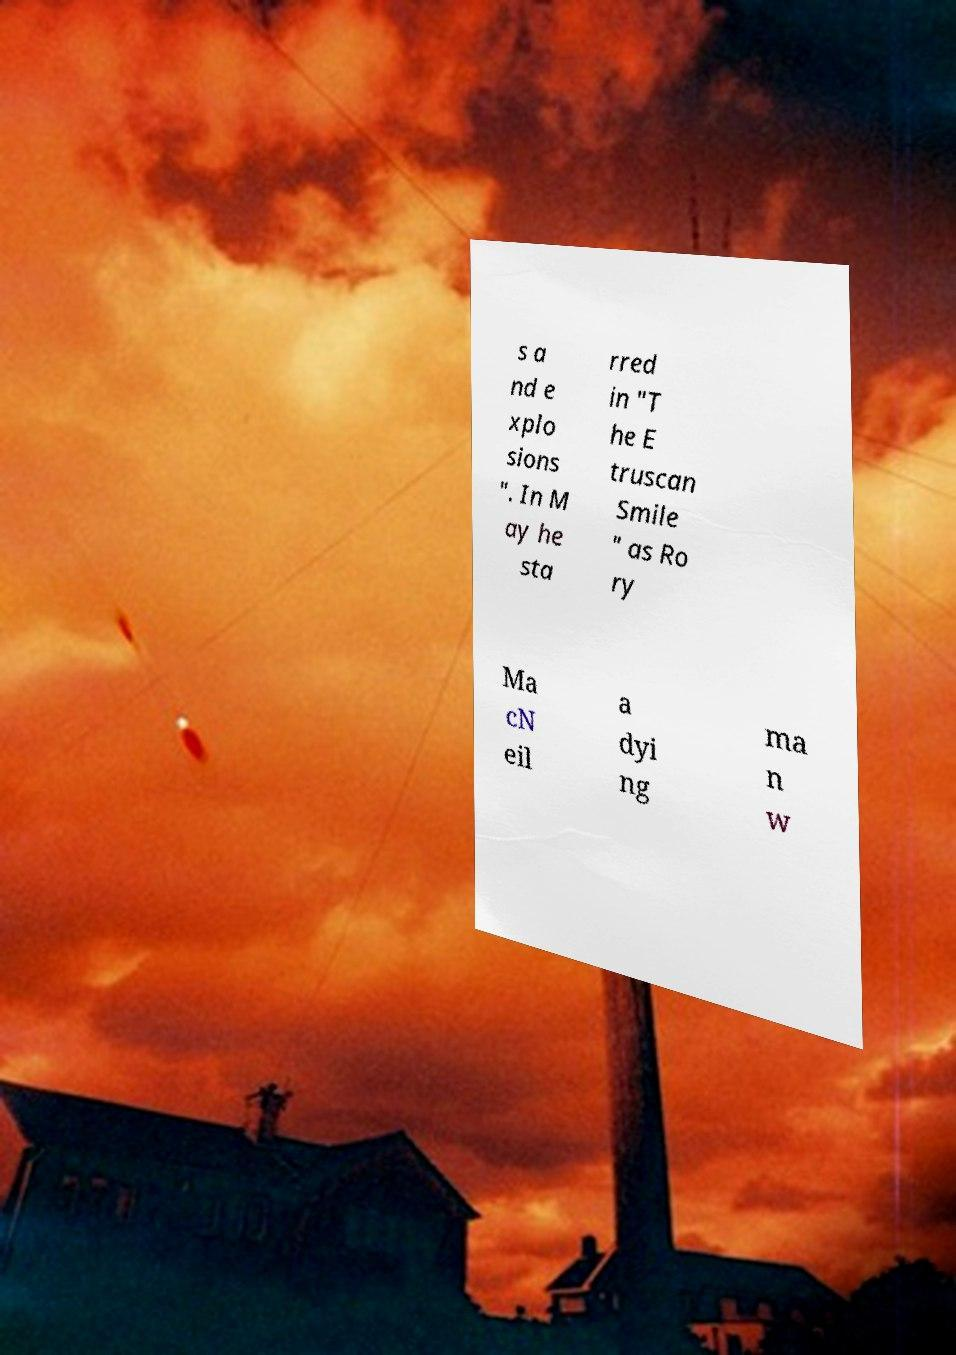Could you extract and type out the text from this image? s a nd e xplo sions ". In M ay he sta rred in "T he E truscan Smile " as Ro ry Ma cN eil a dyi ng ma n w 